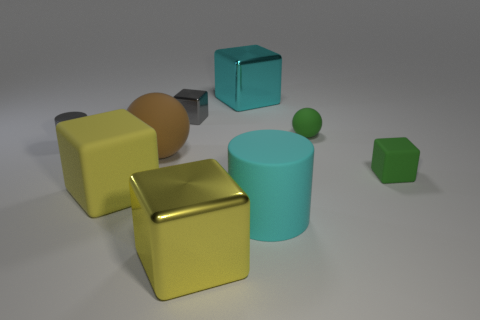Subtract all yellow blocks. How many blocks are left? 3 Subtract all brown cylinders. How many yellow blocks are left? 2 Add 1 cyan rubber cylinders. How many objects exist? 10 Subtract 1 cubes. How many cubes are left? 4 Subtract all cyan cylinders. How many cylinders are left? 1 Subtract all spheres. How many objects are left? 7 Subtract all red cylinders. Subtract all gray blocks. How many cylinders are left? 2 Subtract all tiny yellow rubber objects. Subtract all gray things. How many objects are left? 7 Add 6 gray cylinders. How many gray cylinders are left? 7 Add 1 small gray objects. How many small gray objects exist? 3 